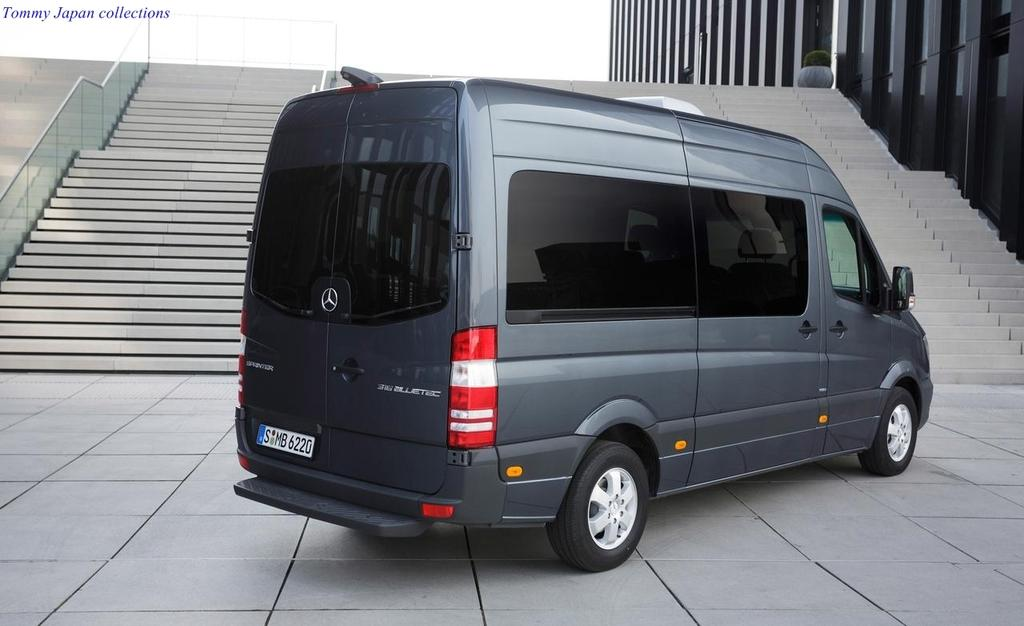<image>
Offer a succinct explanation of the picture presented. A Mercedes Sprinter van with license plate S MB 6220 is parked on concrete in front of many stairs. 